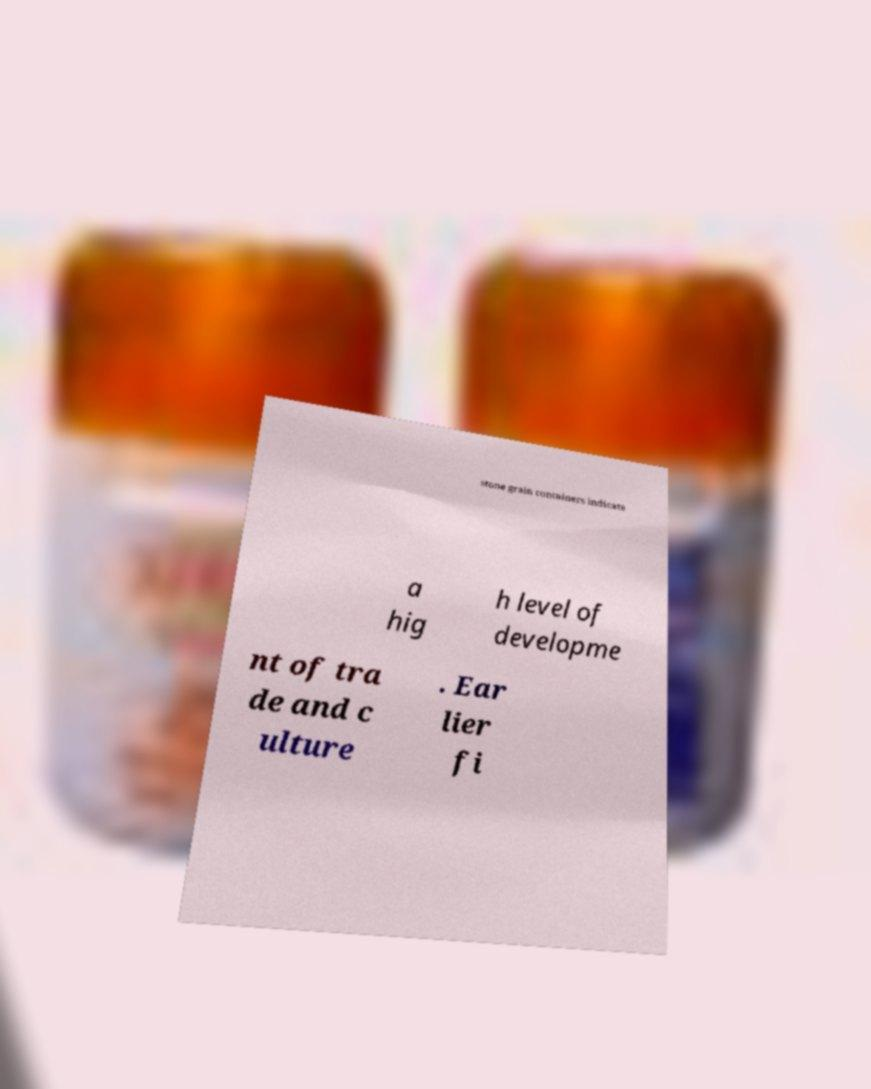Could you assist in decoding the text presented in this image and type it out clearly? stone grain containers indicate a hig h level of developme nt of tra de and c ulture . Ear lier fi 